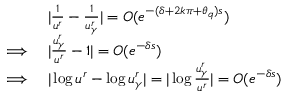<formula> <loc_0><loc_0><loc_500><loc_500>\begin{array} { r l } & { | \frac { 1 } { u ^ { r } } - \frac { 1 } { u _ { \gamma } ^ { r } } | = O ( e ^ { - ( \delta + 2 k \pi + \theta _ { q } ) s } ) } \\ { \implies } & { | \frac { u _ { \gamma } ^ { r } } { u ^ { r } } - 1 | = O ( e ^ { - \delta s } ) } \\ { \implies } & { | \log u ^ { r } - \log u _ { \gamma } ^ { r } | = | \log \frac { u _ { \gamma } ^ { r } } { u ^ { r } } | = O ( e ^ { - \delta s } ) } \end{array}</formula> 